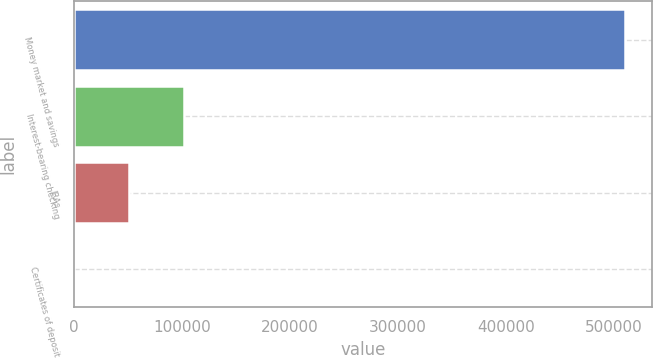Convert chart to OTSL. <chart><loc_0><loc_0><loc_500><loc_500><bar_chart><fcel>Money market and savings<fcel>Interest-bearing checking<fcel>IRAs<fcel>Certificates of deposit<nl><fcel>509915<fcel>102445<fcel>51511.7<fcel>578<nl></chart> 